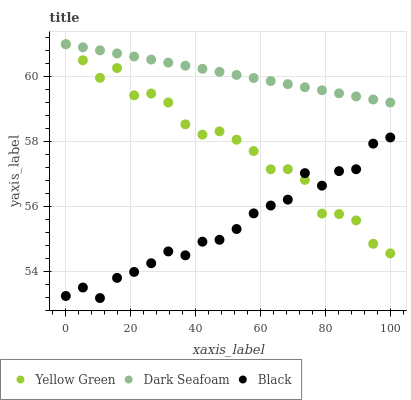Does Black have the minimum area under the curve?
Answer yes or no. Yes. Does Dark Seafoam have the maximum area under the curve?
Answer yes or no. Yes. Does Yellow Green have the minimum area under the curve?
Answer yes or no. No. Does Yellow Green have the maximum area under the curve?
Answer yes or no. No. Is Dark Seafoam the smoothest?
Answer yes or no. Yes. Is Yellow Green the roughest?
Answer yes or no. Yes. Is Black the smoothest?
Answer yes or no. No. Is Black the roughest?
Answer yes or no. No. Does Black have the lowest value?
Answer yes or no. Yes. Does Yellow Green have the lowest value?
Answer yes or no. No. Does Yellow Green have the highest value?
Answer yes or no. Yes. Does Black have the highest value?
Answer yes or no. No. Is Black less than Dark Seafoam?
Answer yes or no. Yes. Is Dark Seafoam greater than Black?
Answer yes or no. Yes. Does Black intersect Yellow Green?
Answer yes or no. Yes. Is Black less than Yellow Green?
Answer yes or no. No. Is Black greater than Yellow Green?
Answer yes or no. No. Does Black intersect Dark Seafoam?
Answer yes or no. No. 